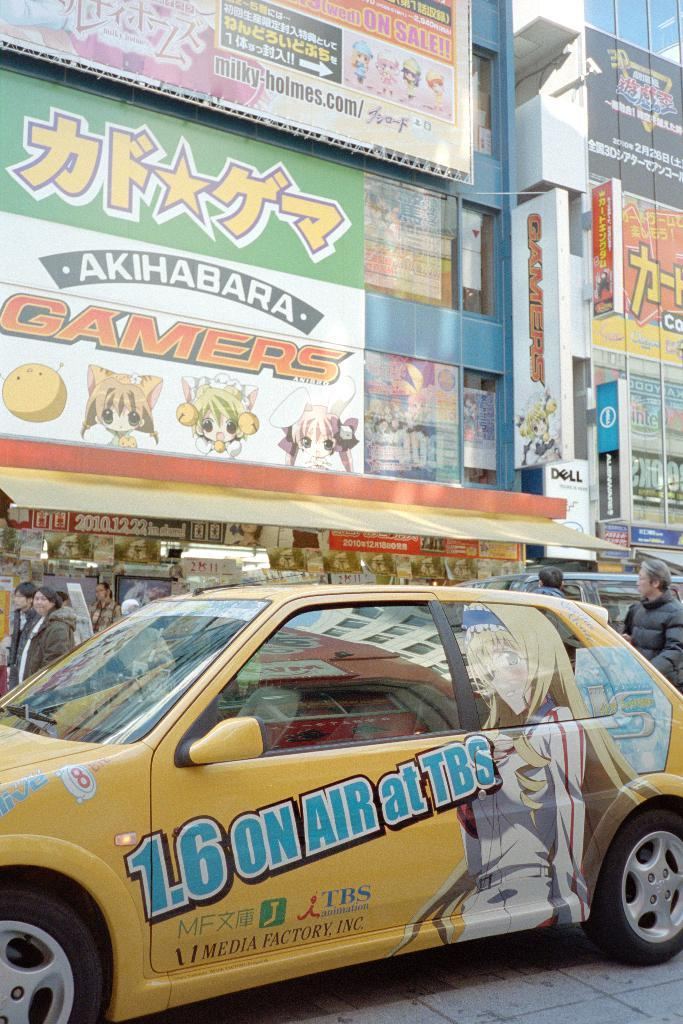<image>
Write a terse but informative summary of the picture. A yellow car with anime characters on it is driving past a building that says Gamers. 